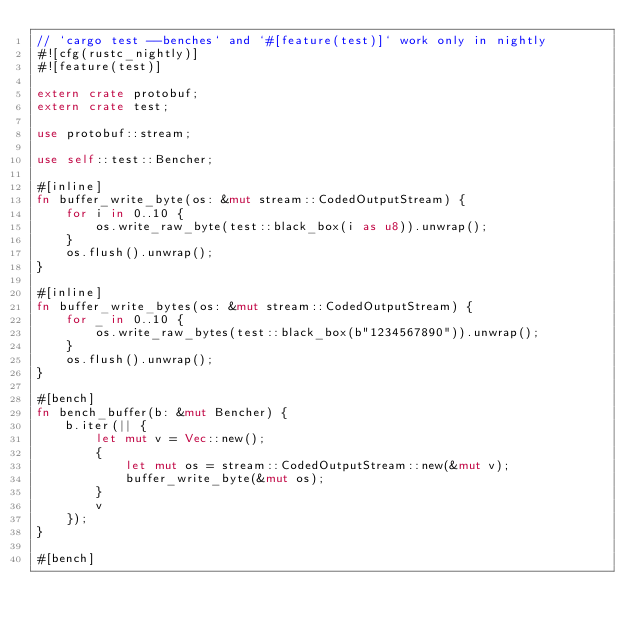<code> <loc_0><loc_0><loc_500><loc_500><_Rust_>// `cargo test --benches` and `#[feature(test)]` work only in nightly
#![cfg(rustc_nightly)]
#![feature(test)]

extern crate protobuf;
extern crate test;

use protobuf::stream;

use self::test::Bencher;

#[inline]
fn buffer_write_byte(os: &mut stream::CodedOutputStream) {
    for i in 0..10 {
        os.write_raw_byte(test::black_box(i as u8)).unwrap();
    }
    os.flush().unwrap();
}

#[inline]
fn buffer_write_bytes(os: &mut stream::CodedOutputStream) {
    for _ in 0..10 {
        os.write_raw_bytes(test::black_box(b"1234567890")).unwrap();
    }
    os.flush().unwrap();
}

#[bench]
fn bench_buffer(b: &mut Bencher) {
    b.iter(|| {
        let mut v = Vec::new();
        {
            let mut os = stream::CodedOutputStream::new(&mut v);
            buffer_write_byte(&mut os);
        }
        v
    });
}

#[bench]</code> 